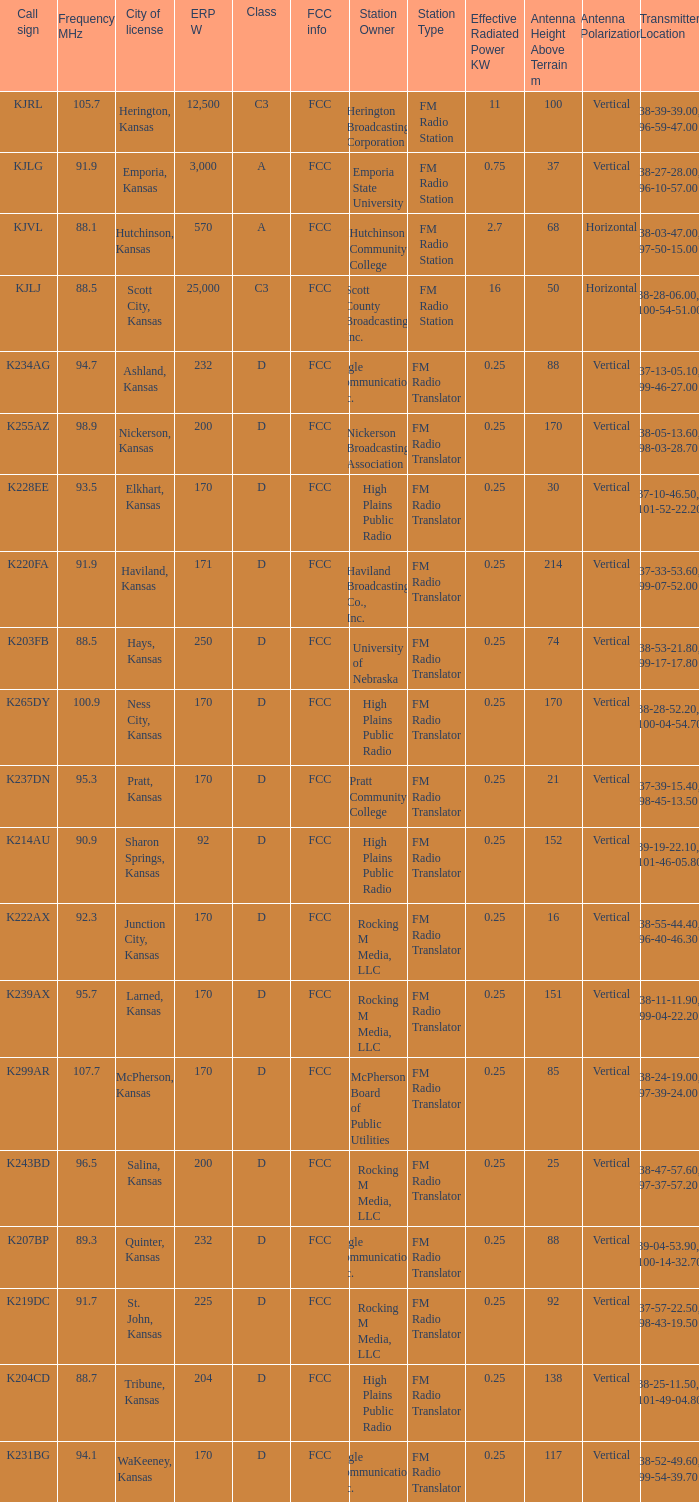Class of d, and a Frequency MHz smaller than 107.7, and a ERP W smaller than 232 has what call sign? K255AZ, K228EE, K220FA, K265DY, K237DN, K214AU, K222AX, K239AX, K243BD, K219DC, K204CD, K231BG. 